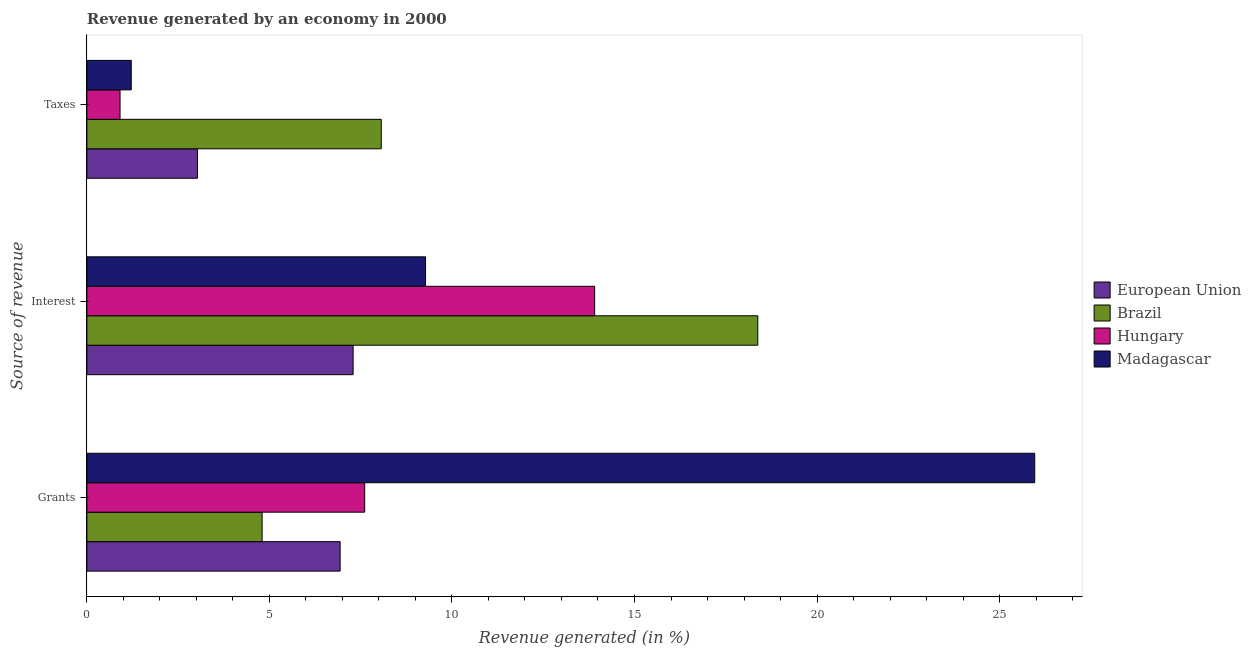Are the number of bars per tick equal to the number of legend labels?
Ensure brevity in your answer.  Yes. How many bars are there on the 1st tick from the top?
Offer a very short reply. 4. How many bars are there on the 2nd tick from the bottom?
Ensure brevity in your answer.  4. What is the label of the 3rd group of bars from the top?
Give a very brief answer. Grants. What is the percentage of revenue generated by interest in Brazil?
Ensure brevity in your answer.  18.38. Across all countries, what is the maximum percentage of revenue generated by taxes?
Give a very brief answer. 8.06. Across all countries, what is the minimum percentage of revenue generated by interest?
Provide a short and direct response. 7.29. In which country was the percentage of revenue generated by grants maximum?
Offer a terse response. Madagascar. What is the total percentage of revenue generated by taxes in the graph?
Make the answer very short. 13.22. What is the difference between the percentage of revenue generated by taxes in Hungary and that in Brazil?
Give a very brief answer. -7.16. What is the difference between the percentage of revenue generated by grants in Hungary and the percentage of revenue generated by interest in Brazil?
Offer a terse response. -10.77. What is the average percentage of revenue generated by taxes per country?
Provide a short and direct response. 3.3. What is the difference between the percentage of revenue generated by taxes and percentage of revenue generated by grants in Brazil?
Give a very brief answer. 3.26. What is the ratio of the percentage of revenue generated by grants in Hungary to that in Madagascar?
Give a very brief answer. 0.29. What is the difference between the highest and the second highest percentage of revenue generated by grants?
Make the answer very short. 18.35. What is the difference between the highest and the lowest percentage of revenue generated by grants?
Your answer should be very brief. 21.16. In how many countries, is the percentage of revenue generated by taxes greater than the average percentage of revenue generated by taxes taken over all countries?
Keep it short and to the point. 1. Is the sum of the percentage of revenue generated by grants in European Union and Hungary greater than the maximum percentage of revenue generated by taxes across all countries?
Offer a terse response. Yes. Is it the case that in every country, the sum of the percentage of revenue generated by grants and percentage of revenue generated by interest is greater than the percentage of revenue generated by taxes?
Provide a succinct answer. Yes. How many bars are there?
Your answer should be very brief. 12. Are all the bars in the graph horizontal?
Make the answer very short. Yes. How many countries are there in the graph?
Offer a terse response. 4. What is the difference between two consecutive major ticks on the X-axis?
Give a very brief answer. 5. Where does the legend appear in the graph?
Ensure brevity in your answer.  Center right. What is the title of the graph?
Provide a short and direct response. Revenue generated by an economy in 2000. Does "Thailand" appear as one of the legend labels in the graph?
Offer a terse response. No. What is the label or title of the X-axis?
Provide a short and direct response. Revenue generated (in %). What is the label or title of the Y-axis?
Keep it short and to the point. Source of revenue. What is the Revenue generated (in %) of European Union in Grants?
Keep it short and to the point. 6.94. What is the Revenue generated (in %) of Brazil in Grants?
Offer a very short reply. 4.8. What is the Revenue generated (in %) in Hungary in Grants?
Provide a succinct answer. 7.61. What is the Revenue generated (in %) in Madagascar in Grants?
Offer a terse response. 25.96. What is the Revenue generated (in %) in European Union in Interest?
Your answer should be compact. 7.29. What is the Revenue generated (in %) of Brazil in Interest?
Ensure brevity in your answer.  18.38. What is the Revenue generated (in %) of Hungary in Interest?
Give a very brief answer. 13.91. What is the Revenue generated (in %) of Madagascar in Interest?
Keep it short and to the point. 9.28. What is the Revenue generated (in %) in European Union in Taxes?
Keep it short and to the point. 3.03. What is the Revenue generated (in %) of Brazil in Taxes?
Your response must be concise. 8.06. What is the Revenue generated (in %) in Hungary in Taxes?
Make the answer very short. 0.91. What is the Revenue generated (in %) of Madagascar in Taxes?
Give a very brief answer. 1.22. Across all Source of revenue, what is the maximum Revenue generated (in %) in European Union?
Provide a succinct answer. 7.29. Across all Source of revenue, what is the maximum Revenue generated (in %) of Brazil?
Keep it short and to the point. 18.38. Across all Source of revenue, what is the maximum Revenue generated (in %) in Hungary?
Your answer should be very brief. 13.91. Across all Source of revenue, what is the maximum Revenue generated (in %) of Madagascar?
Your answer should be very brief. 25.96. Across all Source of revenue, what is the minimum Revenue generated (in %) in European Union?
Your answer should be very brief. 3.03. Across all Source of revenue, what is the minimum Revenue generated (in %) of Brazil?
Offer a terse response. 4.8. Across all Source of revenue, what is the minimum Revenue generated (in %) of Hungary?
Your response must be concise. 0.91. Across all Source of revenue, what is the minimum Revenue generated (in %) of Madagascar?
Your answer should be compact. 1.22. What is the total Revenue generated (in %) of European Union in the graph?
Your answer should be very brief. 17.26. What is the total Revenue generated (in %) in Brazil in the graph?
Provide a short and direct response. 31.24. What is the total Revenue generated (in %) in Hungary in the graph?
Your answer should be compact. 22.43. What is the total Revenue generated (in %) of Madagascar in the graph?
Provide a succinct answer. 36.46. What is the difference between the Revenue generated (in %) in European Union in Grants and that in Interest?
Offer a terse response. -0.36. What is the difference between the Revenue generated (in %) in Brazil in Grants and that in Interest?
Your answer should be compact. -13.58. What is the difference between the Revenue generated (in %) in Hungary in Grants and that in Interest?
Your answer should be very brief. -6.3. What is the difference between the Revenue generated (in %) of Madagascar in Grants and that in Interest?
Give a very brief answer. 16.69. What is the difference between the Revenue generated (in %) of European Union in Grants and that in Taxes?
Offer a very short reply. 3.91. What is the difference between the Revenue generated (in %) of Brazil in Grants and that in Taxes?
Offer a terse response. -3.26. What is the difference between the Revenue generated (in %) of Hungary in Grants and that in Taxes?
Offer a very short reply. 6.7. What is the difference between the Revenue generated (in %) of Madagascar in Grants and that in Taxes?
Keep it short and to the point. 24.75. What is the difference between the Revenue generated (in %) in European Union in Interest and that in Taxes?
Ensure brevity in your answer.  4.26. What is the difference between the Revenue generated (in %) of Brazil in Interest and that in Taxes?
Your answer should be very brief. 10.31. What is the difference between the Revenue generated (in %) of Hungary in Interest and that in Taxes?
Your response must be concise. 13. What is the difference between the Revenue generated (in %) of Madagascar in Interest and that in Taxes?
Your answer should be compact. 8.06. What is the difference between the Revenue generated (in %) of European Union in Grants and the Revenue generated (in %) of Brazil in Interest?
Offer a terse response. -11.44. What is the difference between the Revenue generated (in %) of European Union in Grants and the Revenue generated (in %) of Hungary in Interest?
Make the answer very short. -6.97. What is the difference between the Revenue generated (in %) in European Union in Grants and the Revenue generated (in %) in Madagascar in Interest?
Ensure brevity in your answer.  -2.34. What is the difference between the Revenue generated (in %) in Brazil in Grants and the Revenue generated (in %) in Hungary in Interest?
Provide a succinct answer. -9.11. What is the difference between the Revenue generated (in %) in Brazil in Grants and the Revenue generated (in %) in Madagascar in Interest?
Keep it short and to the point. -4.48. What is the difference between the Revenue generated (in %) of Hungary in Grants and the Revenue generated (in %) of Madagascar in Interest?
Provide a short and direct response. -1.67. What is the difference between the Revenue generated (in %) in European Union in Grants and the Revenue generated (in %) in Brazil in Taxes?
Your answer should be compact. -1.13. What is the difference between the Revenue generated (in %) of European Union in Grants and the Revenue generated (in %) of Hungary in Taxes?
Keep it short and to the point. 6.03. What is the difference between the Revenue generated (in %) in European Union in Grants and the Revenue generated (in %) in Madagascar in Taxes?
Make the answer very short. 5.72. What is the difference between the Revenue generated (in %) of Brazil in Grants and the Revenue generated (in %) of Hungary in Taxes?
Offer a very short reply. 3.89. What is the difference between the Revenue generated (in %) of Brazil in Grants and the Revenue generated (in %) of Madagascar in Taxes?
Ensure brevity in your answer.  3.58. What is the difference between the Revenue generated (in %) in Hungary in Grants and the Revenue generated (in %) in Madagascar in Taxes?
Provide a succinct answer. 6.39. What is the difference between the Revenue generated (in %) in European Union in Interest and the Revenue generated (in %) in Brazil in Taxes?
Make the answer very short. -0.77. What is the difference between the Revenue generated (in %) in European Union in Interest and the Revenue generated (in %) in Hungary in Taxes?
Your answer should be compact. 6.38. What is the difference between the Revenue generated (in %) in European Union in Interest and the Revenue generated (in %) in Madagascar in Taxes?
Your answer should be compact. 6.08. What is the difference between the Revenue generated (in %) in Brazil in Interest and the Revenue generated (in %) in Hungary in Taxes?
Offer a terse response. 17.47. What is the difference between the Revenue generated (in %) in Brazil in Interest and the Revenue generated (in %) in Madagascar in Taxes?
Offer a very short reply. 17.16. What is the difference between the Revenue generated (in %) of Hungary in Interest and the Revenue generated (in %) of Madagascar in Taxes?
Ensure brevity in your answer.  12.69. What is the average Revenue generated (in %) of European Union per Source of revenue?
Your response must be concise. 5.75. What is the average Revenue generated (in %) of Brazil per Source of revenue?
Your answer should be very brief. 10.41. What is the average Revenue generated (in %) in Hungary per Source of revenue?
Offer a terse response. 7.48. What is the average Revenue generated (in %) of Madagascar per Source of revenue?
Your response must be concise. 12.15. What is the difference between the Revenue generated (in %) in European Union and Revenue generated (in %) in Brazil in Grants?
Offer a terse response. 2.14. What is the difference between the Revenue generated (in %) of European Union and Revenue generated (in %) of Hungary in Grants?
Give a very brief answer. -0.67. What is the difference between the Revenue generated (in %) in European Union and Revenue generated (in %) in Madagascar in Grants?
Provide a succinct answer. -19.03. What is the difference between the Revenue generated (in %) of Brazil and Revenue generated (in %) of Hungary in Grants?
Offer a very short reply. -2.81. What is the difference between the Revenue generated (in %) in Brazil and Revenue generated (in %) in Madagascar in Grants?
Offer a very short reply. -21.16. What is the difference between the Revenue generated (in %) of Hungary and Revenue generated (in %) of Madagascar in Grants?
Your answer should be compact. -18.35. What is the difference between the Revenue generated (in %) of European Union and Revenue generated (in %) of Brazil in Interest?
Offer a terse response. -11.09. What is the difference between the Revenue generated (in %) of European Union and Revenue generated (in %) of Hungary in Interest?
Provide a succinct answer. -6.62. What is the difference between the Revenue generated (in %) of European Union and Revenue generated (in %) of Madagascar in Interest?
Your response must be concise. -1.98. What is the difference between the Revenue generated (in %) in Brazil and Revenue generated (in %) in Hungary in Interest?
Your answer should be very brief. 4.47. What is the difference between the Revenue generated (in %) in Brazil and Revenue generated (in %) in Madagascar in Interest?
Keep it short and to the point. 9.1. What is the difference between the Revenue generated (in %) in Hungary and Revenue generated (in %) in Madagascar in Interest?
Make the answer very short. 4.63. What is the difference between the Revenue generated (in %) in European Union and Revenue generated (in %) in Brazil in Taxes?
Provide a succinct answer. -5.03. What is the difference between the Revenue generated (in %) in European Union and Revenue generated (in %) in Hungary in Taxes?
Your answer should be very brief. 2.12. What is the difference between the Revenue generated (in %) in European Union and Revenue generated (in %) in Madagascar in Taxes?
Your answer should be very brief. 1.81. What is the difference between the Revenue generated (in %) in Brazil and Revenue generated (in %) in Hungary in Taxes?
Make the answer very short. 7.16. What is the difference between the Revenue generated (in %) in Brazil and Revenue generated (in %) in Madagascar in Taxes?
Offer a terse response. 6.85. What is the difference between the Revenue generated (in %) of Hungary and Revenue generated (in %) of Madagascar in Taxes?
Make the answer very short. -0.31. What is the ratio of the Revenue generated (in %) of European Union in Grants to that in Interest?
Provide a succinct answer. 0.95. What is the ratio of the Revenue generated (in %) of Brazil in Grants to that in Interest?
Give a very brief answer. 0.26. What is the ratio of the Revenue generated (in %) in Hungary in Grants to that in Interest?
Your answer should be compact. 0.55. What is the ratio of the Revenue generated (in %) in Madagascar in Grants to that in Interest?
Your answer should be very brief. 2.8. What is the ratio of the Revenue generated (in %) of European Union in Grants to that in Taxes?
Your answer should be compact. 2.29. What is the ratio of the Revenue generated (in %) of Brazil in Grants to that in Taxes?
Your response must be concise. 0.6. What is the ratio of the Revenue generated (in %) in Hungary in Grants to that in Taxes?
Your answer should be compact. 8.37. What is the ratio of the Revenue generated (in %) in Madagascar in Grants to that in Taxes?
Your response must be concise. 21.36. What is the ratio of the Revenue generated (in %) in European Union in Interest to that in Taxes?
Ensure brevity in your answer.  2.41. What is the ratio of the Revenue generated (in %) of Brazil in Interest to that in Taxes?
Provide a succinct answer. 2.28. What is the ratio of the Revenue generated (in %) of Hungary in Interest to that in Taxes?
Offer a terse response. 15.31. What is the ratio of the Revenue generated (in %) in Madagascar in Interest to that in Taxes?
Provide a succinct answer. 7.63. What is the difference between the highest and the second highest Revenue generated (in %) of European Union?
Make the answer very short. 0.36. What is the difference between the highest and the second highest Revenue generated (in %) in Brazil?
Your answer should be very brief. 10.31. What is the difference between the highest and the second highest Revenue generated (in %) in Hungary?
Make the answer very short. 6.3. What is the difference between the highest and the second highest Revenue generated (in %) in Madagascar?
Your response must be concise. 16.69. What is the difference between the highest and the lowest Revenue generated (in %) in European Union?
Give a very brief answer. 4.26. What is the difference between the highest and the lowest Revenue generated (in %) in Brazil?
Provide a succinct answer. 13.58. What is the difference between the highest and the lowest Revenue generated (in %) in Hungary?
Offer a terse response. 13. What is the difference between the highest and the lowest Revenue generated (in %) in Madagascar?
Provide a succinct answer. 24.75. 